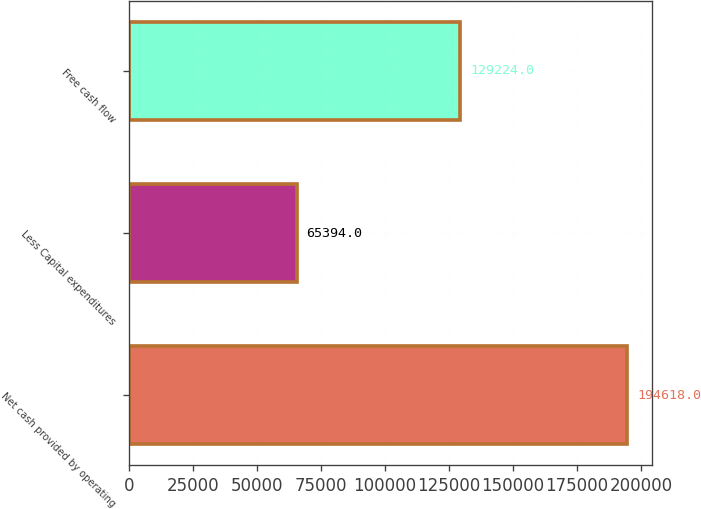Convert chart to OTSL. <chart><loc_0><loc_0><loc_500><loc_500><bar_chart><fcel>Net cash provided by operating<fcel>Less Capital expenditures<fcel>Free cash flow<nl><fcel>194618<fcel>65394<fcel>129224<nl></chart> 